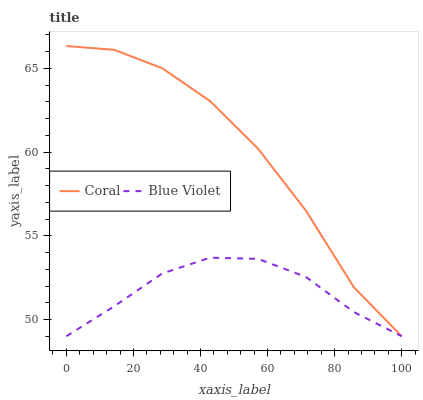Does Blue Violet have the maximum area under the curve?
Answer yes or no. No. Is Blue Violet the roughest?
Answer yes or no. No. Does Blue Violet have the highest value?
Answer yes or no. No. 